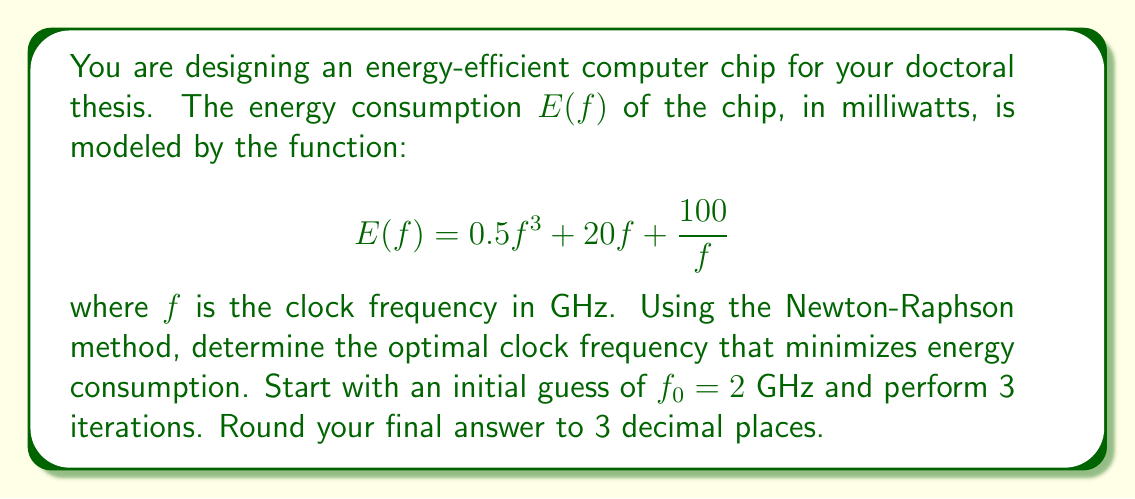Give your solution to this math problem. To find the optimal clock frequency, we need to minimize the energy consumption function $E(f)$. This is done by finding the root of its derivative.

Step 1: Calculate the derivative of $E(f)$
$$E'(f) = 1.5f^2 + 20 - \frac{100}{f^2}$$

Step 2: Apply the Newton-Raphson method
The Newton-Raphson formula is:
$$f_{n+1} = f_n - \frac{E'(f_n)}{E''(f_n)}$$

We need to calculate $E''(f)$:
$$E''(f) = 3f + \frac{200}{f^3}$$

Step 3: Perform 3 iterations

Iteration 1:
$$f_1 = 2 - \frac{1.5(2)^2 + 20 - \frac{100}{2^2}}{3(2) + \frac{200}{2^3}} = 2 - \frac{26}{28} = 1.0714$$

Iteration 2:
$$f_2 = 1.0714 - \frac{1.5(1.0714)^2 + 20 - \frac{100}{1.0714^2}}{3(1.0714) + \frac{200}{1.0714^3}} = 1.0714 - \frac{-5.8916}{93.4605} = 1.1344$$

Iteration 3:
$$f_3 = 1.1344 - \frac{1.5(1.1344)^2 + 20 - \frac{100}{1.1344^2}}{3(1.1344) + \frac{200}{1.1344^3}} = 1.1344 - \frac{-0.2791}{79.1651} = 1.1379$$

Step 4: Round the result to 3 decimal places
The final answer is 1.138 GHz.
Answer: 1.138 GHz 